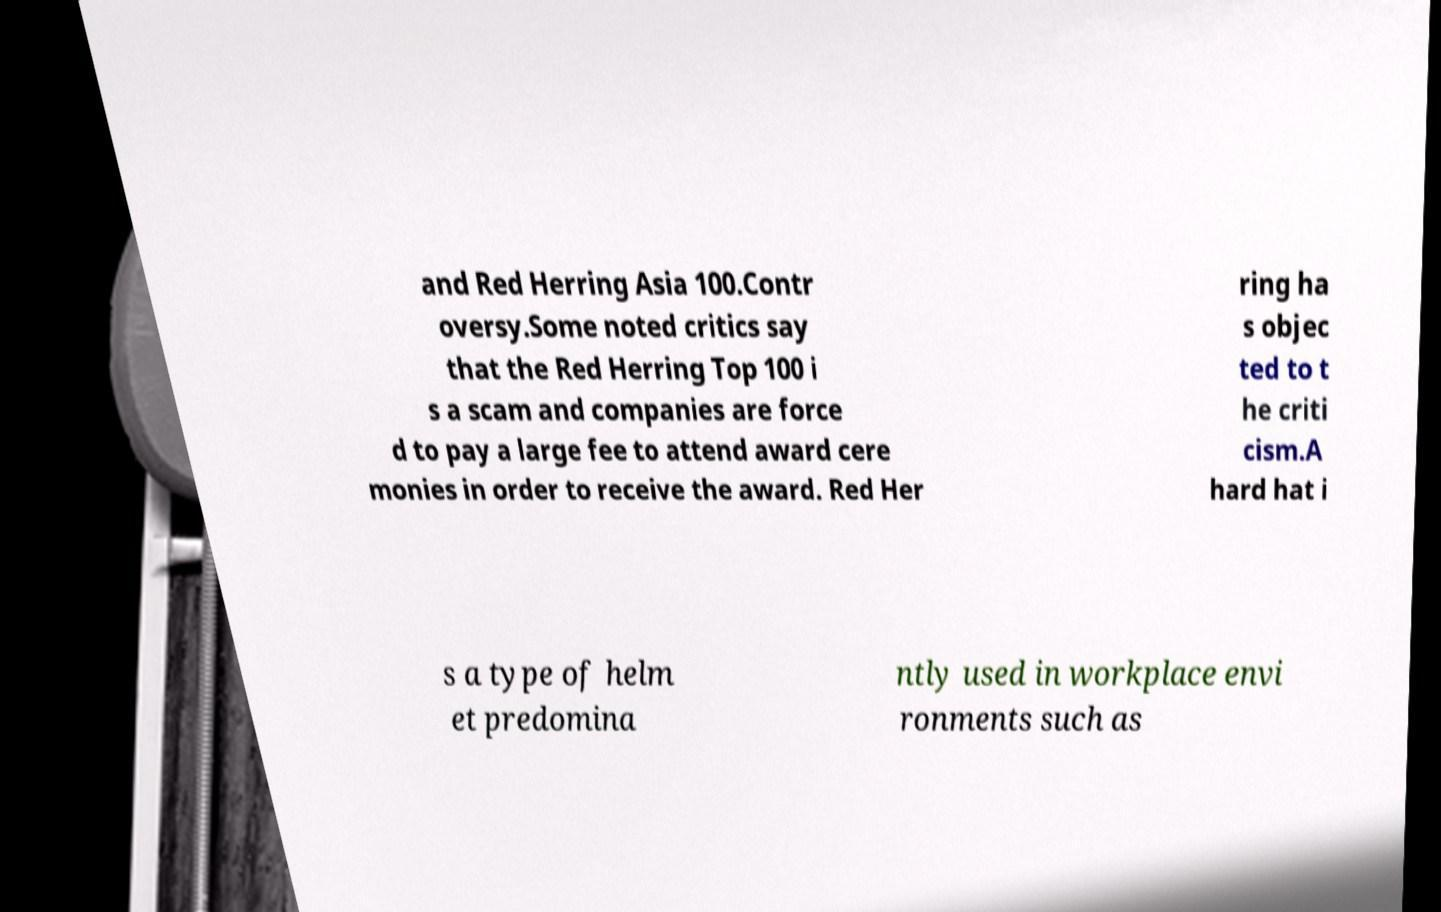Could you extract and type out the text from this image? and Red Herring Asia 100.Contr oversy.Some noted critics say that the Red Herring Top 100 i s a scam and companies are force d to pay a large fee to attend award cere monies in order to receive the award. Red Her ring ha s objec ted to t he criti cism.A hard hat i s a type of helm et predomina ntly used in workplace envi ronments such as 